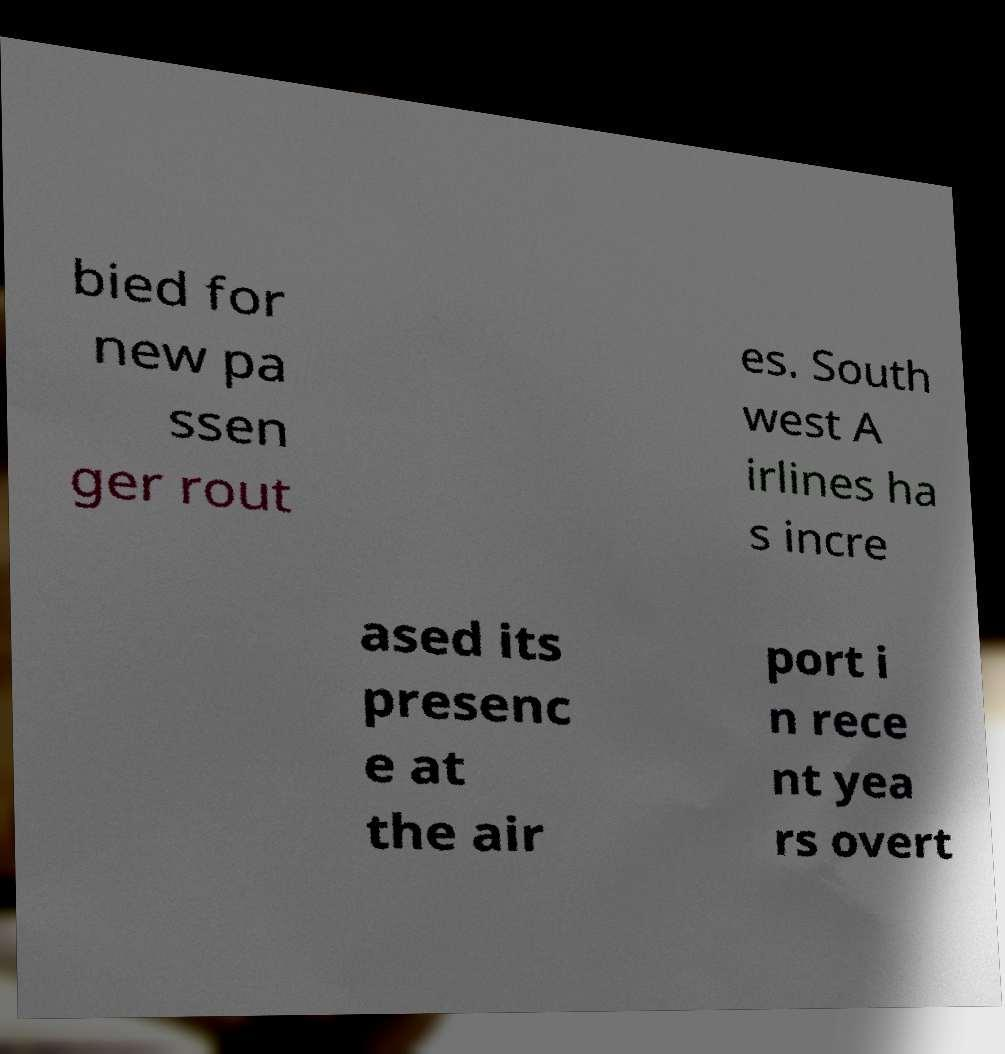What messages or text are displayed in this image? I need them in a readable, typed format. bied for new pa ssen ger rout es. South west A irlines ha s incre ased its presenc e at the air port i n rece nt yea rs overt 